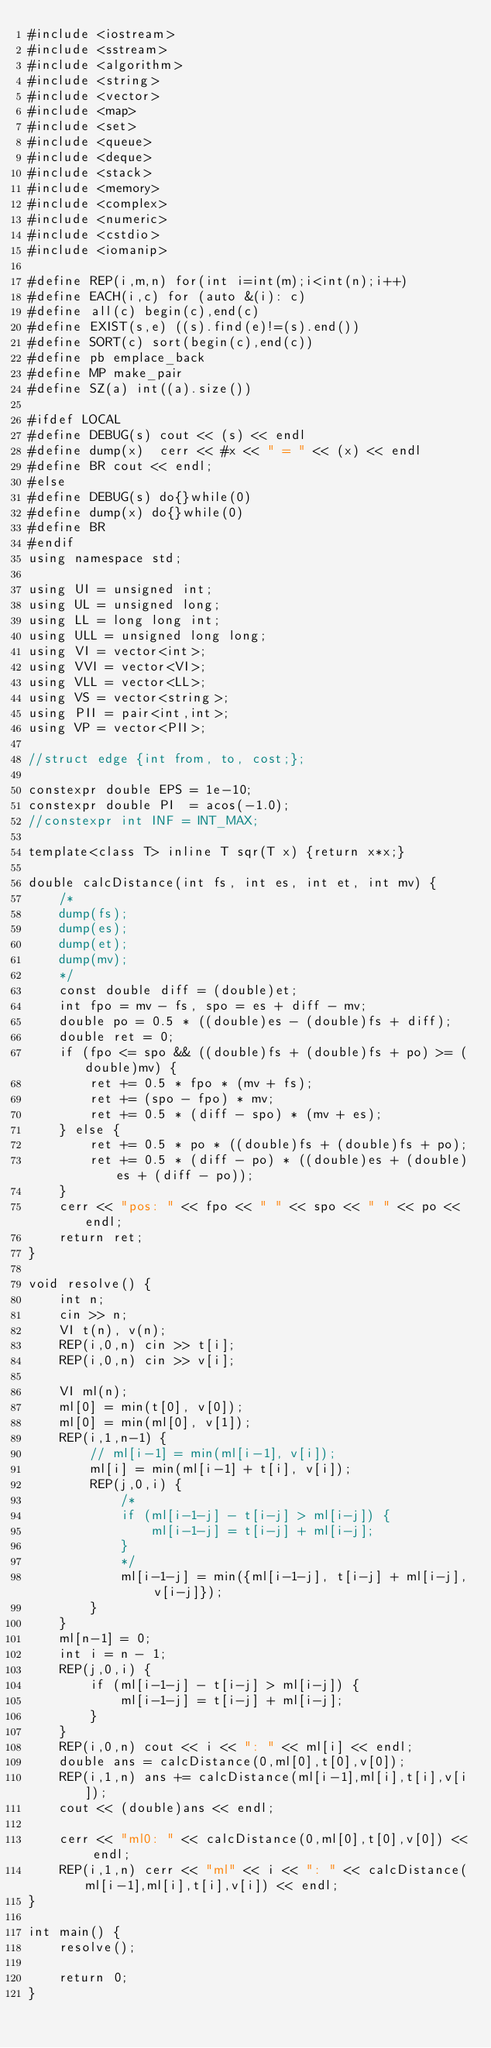<code> <loc_0><loc_0><loc_500><loc_500><_C++_>#include <iostream>
#include <sstream>
#include <algorithm>
#include <string>
#include <vector>
#include <map>
#include <set>
#include <queue>
#include <deque>
#include <stack>
#include <memory>
#include <complex>
#include <numeric>
#include <cstdio>
#include <iomanip>

#define REP(i,m,n) for(int i=int(m);i<int(n);i++)
#define EACH(i,c) for (auto &(i): c)
#define all(c) begin(c),end(c)
#define EXIST(s,e) ((s).find(e)!=(s).end())
#define SORT(c) sort(begin(c),end(c))
#define pb emplace_back
#define MP make_pair
#define SZ(a) int((a).size())

#ifdef LOCAL
#define DEBUG(s) cout << (s) << endl
#define dump(x)  cerr << #x << " = " << (x) << endl
#define BR cout << endl;
#else
#define DEBUG(s) do{}while(0)
#define dump(x) do{}while(0)
#define BR 
#endif
using namespace std;

using UI = unsigned int;
using UL = unsigned long;
using LL = long long int;
using ULL = unsigned long long;
using VI = vector<int>;
using VVI = vector<VI>;
using VLL = vector<LL>;
using VS = vector<string>;
using PII = pair<int,int>;
using VP = vector<PII>;

//struct edge {int from, to, cost;};

constexpr double EPS = 1e-10;
constexpr double PI  = acos(-1.0);
//constexpr int INF = INT_MAX;

template<class T> inline T sqr(T x) {return x*x;}

double calcDistance(int fs, int es, int et, int mv) {
    /*
    dump(fs);
    dump(es);
    dump(et);
    dump(mv);
    */
    const double diff = (double)et;
    int fpo = mv - fs, spo = es + diff - mv;
    double po = 0.5 * ((double)es - (double)fs + diff);
    double ret = 0;
    if (fpo <= spo && ((double)fs + (double)fs + po) >= (double)mv) {
        ret += 0.5 * fpo * (mv + fs);
        ret += (spo - fpo) * mv;
        ret += 0.5 * (diff - spo) * (mv + es);
    } else {
        ret += 0.5 * po * ((double)fs + (double)fs + po);
        ret += 0.5 * (diff - po) * ((double)es + (double)es + (diff - po));
    }
    cerr << "pos: " << fpo << " " << spo << " " << po << endl;
    return ret;
}

void resolve() {
    int n;
    cin >> n;
    VI t(n), v(n);
    REP(i,0,n) cin >> t[i];
    REP(i,0,n) cin >> v[i];

    VI ml(n);
    ml[0] = min(t[0], v[0]);
    ml[0] = min(ml[0], v[1]);
    REP(i,1,n-1) {
        // ml[i-1] = min(ml[i-1], v[i]);
        ml[i] = min(ml[i-1] + t[i], v[i]);
        REP(j,0,i) {
            /*
            if (ml[i-1-j] - t[i-j] > ml[i-j]) {
                ml[i-1-j] = t[i-j] + ml[i-j];
            }
            */
            ml[i-1-j] = min({ml[i-1-j], t[i-j] + ml[i-j], v[i-j]});
        }
    }
    ml[n-1] = 0;
    int i = n - 1;
    REP(j,0,i) {
        if (ml[i-1-j] - t[i-j] > ml[i-j]) {
            ml[i-1-j] = t[i-j] + ml[i-j];
        }
    }
    REP(i,0,n) cout << i << ": " << ml[i] << endl;
    double ans = calcDistance(0,ml[0],t[0],v[0]);
    REP(i,1,n) ans += calcDistance(ml[i-1],ml[i],t[i],v[i]);
    cout << (double)ans << endl;

    cerr << "ml0: " << calcDistance(0,ml[0],t[0],v[0]) << endl;
    REP(i,1,n) cerr << "ml" << i << ": " << calcDistance(ml[i-1],ml[i],t[i],v[i]) << endl;
}

int main() {
    resolve();
    
    return 0;
}</code> 